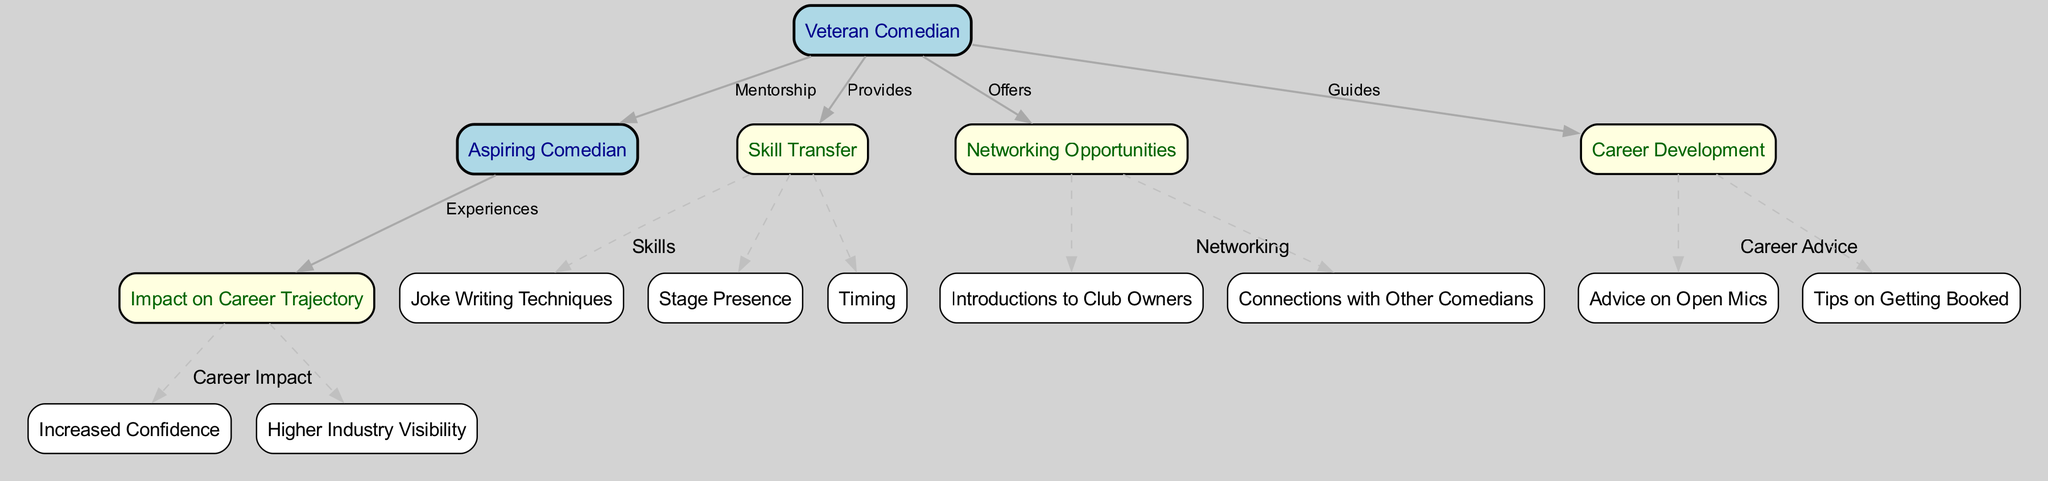What is the main role of the veteran comedian in the diagram? The diagram indicates that the veteran comedian provides mentorship to the aspiring comedian, which is the central role depicted in the diagram.
Answer: Mentorship How many skill transfer aspects are outlined? By reviewing the edges connected to the skill transfer node, we find three specific skills listed: joke writing techniques, stage presence, and timing.
Answer: 3 What connections can the aspiring comedian make through networking? The networking node leads the aspiring comedian to connections with club owners and other comedians, indicating these are the opportunities available.
Answer: Club owners, other comedians What advice does the mentor provide to help in career development? The career development node indicates that the mentor offers advice on open mics and tips on getting booked as part of guiding the aspiring comedian's growth.
Answer: Open mics, gig bookings What are the ultimate impacts on the aspiring comedian's career trajectory? Examining the trajectory impact node reveals that the outcomes include increased confidence and higher industry visibility for the aspiring comedian, mapping out the beneficial effects of mentorship.
Answer: Increased confidence, higher industry visibility What is the relationship between skill transfer and career development? The diagram shows that the skill transfer node is directly linked to the career development node, suggesting that the skills learned directly assist in progressing a comedian's career.
Answer: Direct link How is the mentorship characterized between the mentor and mentee? The edges connecting the mentor to both the mentee and their various benefits (such as skill transfer and networking) highlight that the mentorship fosters multiple supportive interactions.
Answer: Fosters support What is the significance of the trajectory impact node? The trajectory impact node aggregates the positive experiences that the aspiring comedian undergoes, showcasing the long-term effects of mentorship on their career.
Answer: Positive experiences How does the diagram visually separate different categories of support? The diagram uses clusters to visually group nodes by specific categories such as skills, networking, career advice, and career impact, making it easier to understand relationships within each category.
Answer: Clusters 